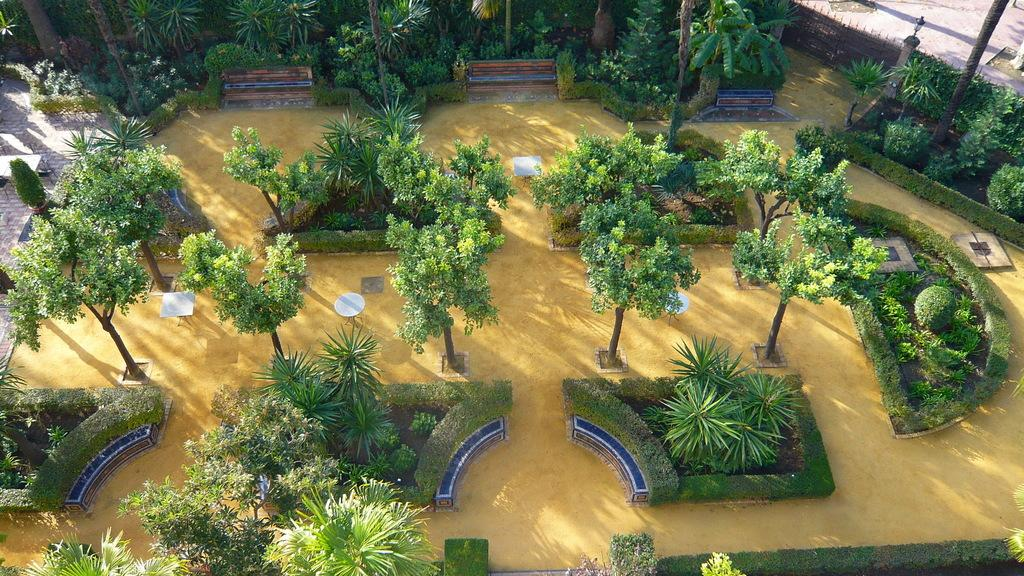What type of vegetation can be seen in the image? There is grass, plants, and trees in the image. What type of furniture is present in the image? There are tables in the image. What is the source of illumination in the image? There is light in the image. What architectural feature can be seen in the image? There is a gate in the image. What type of wine is being served by the giants in the image? There are no giants or wine present in the image. How many cherries are on the trees in the image? There are no cherries mentioned in the image; it only includes grass, plants, trees, tables, light, and a gate. 